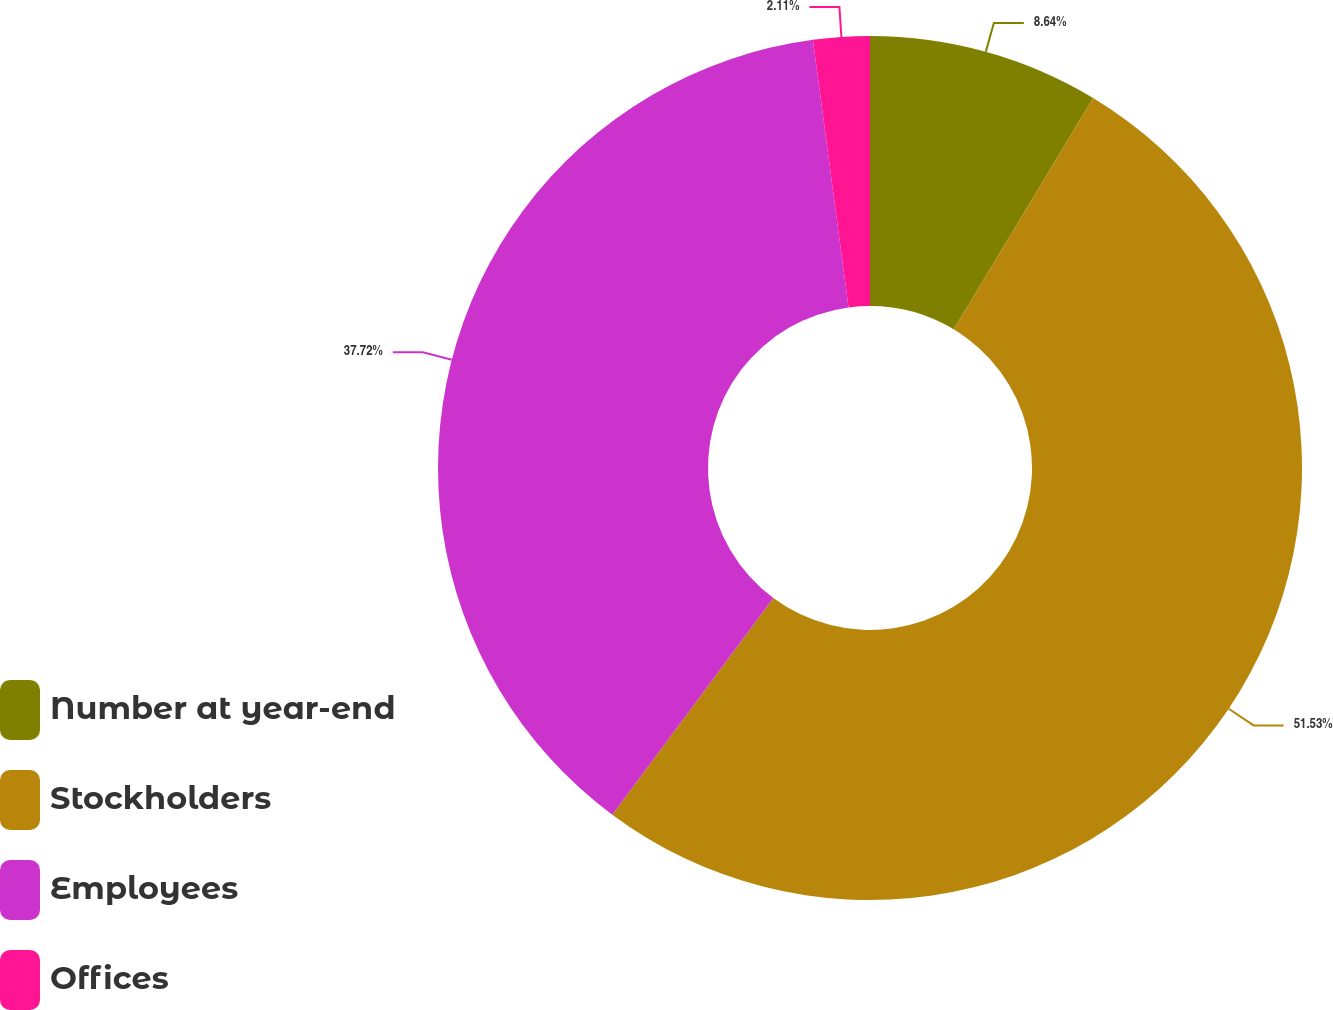Convert chart. <chart><loc_0><loc_0><loc_500><loc_500><pie_chart><fcel>Number at year-end<fcel>Stockholders<fcel>Employees<fcel>Offices<nl><fcel>8.64%<fcel>51.54%<fcel>37.72%<fcel>2.11%<nl></chart> 